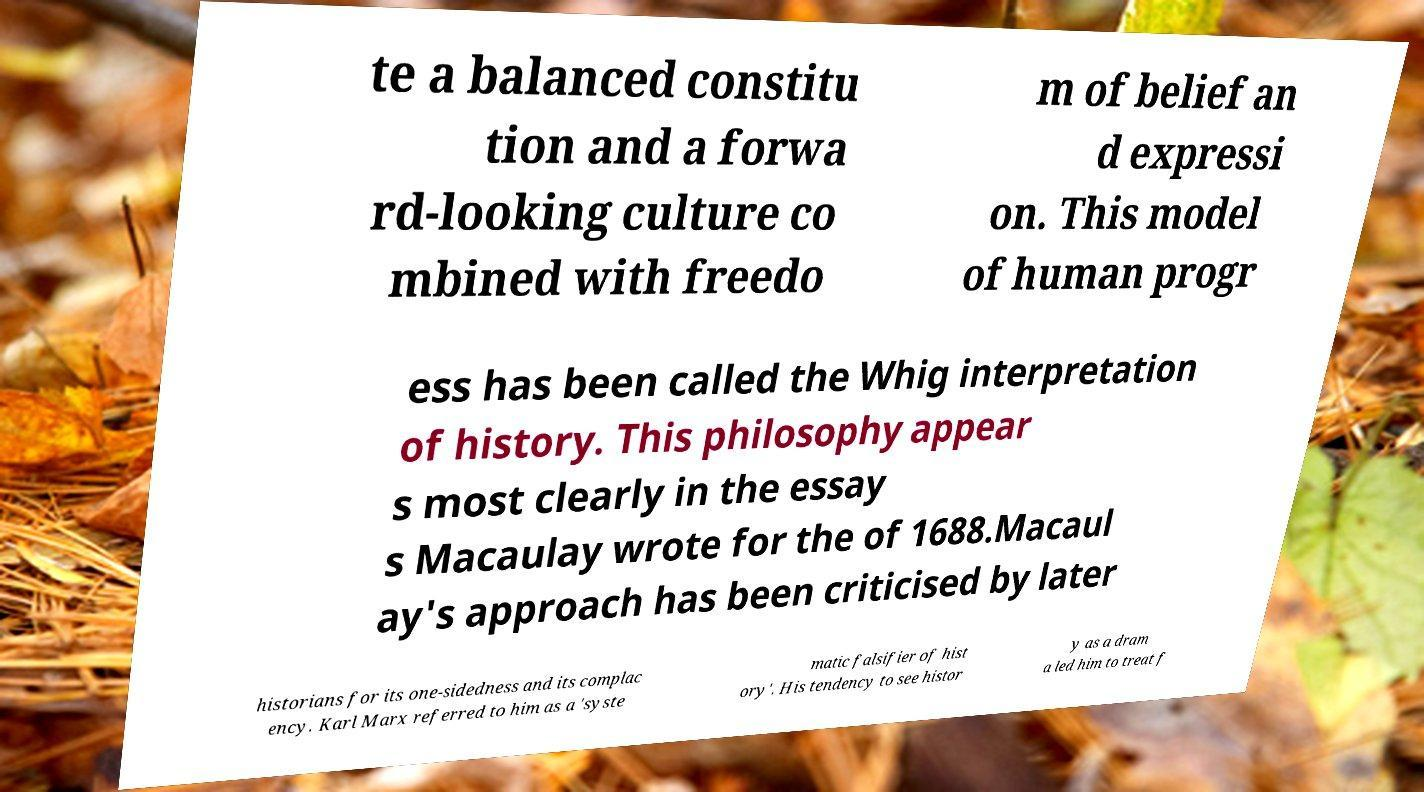What messages or text are displayed in this image? I need them in a readable, typed format. te a balanced constitu tion and a forwa rd-looking culture co mbined with freedo m of belief an d expressi on. This model of human progr ess has been called the Whig interpretation of history. This philosophy appear s most clearly in the essay s Macaulay wrote for the of 1688.Macaul ay's approach has been criticised by later historians for its one-sidedness and its complac ency. Karl Marx referred to him as a 'syste matic falsifier of hist ory'. His tendency to see histor y as a dram a led him to treat f 